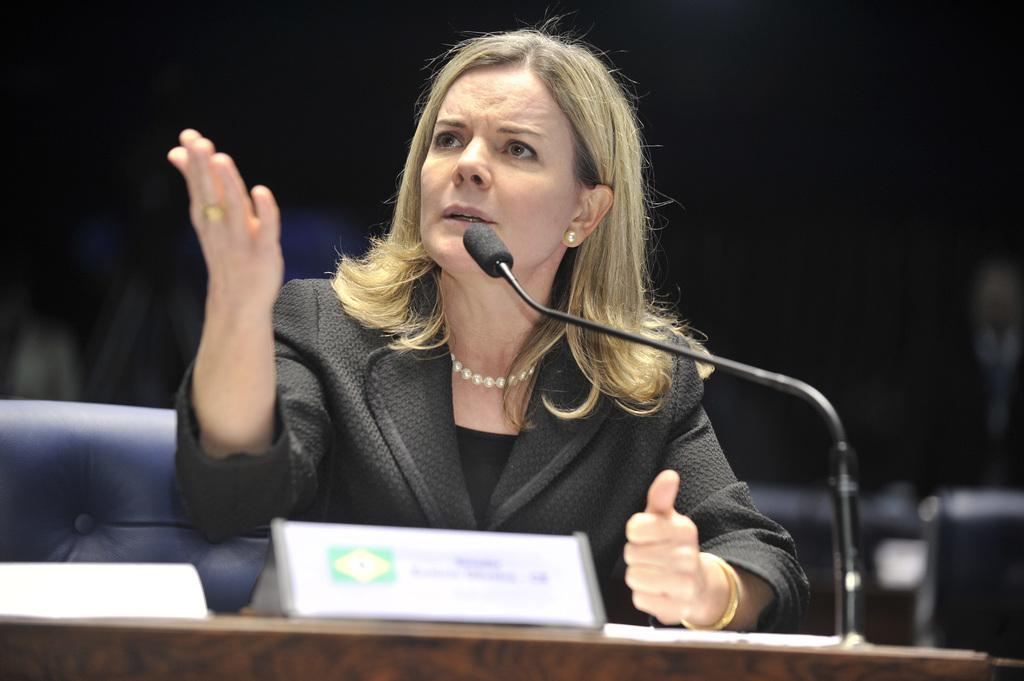Who is the main subject in the image? There is a woman in the image. What is the woman doing in the image? The woman is sitting on a chair and talking. Where is the chair located in relation to the desk? The chair is near a desk. What object is present on the desk? There is a microphone on the desk. What is the woman wearing in the image? The woman is wearing a black blazer. What is the girl's name in the image? There is no girl present in the image; it features a woman. What advice does the mother give to her daughter in the image? There is no mother or daughter present in the image, and therefore no such interaction can be observed. 